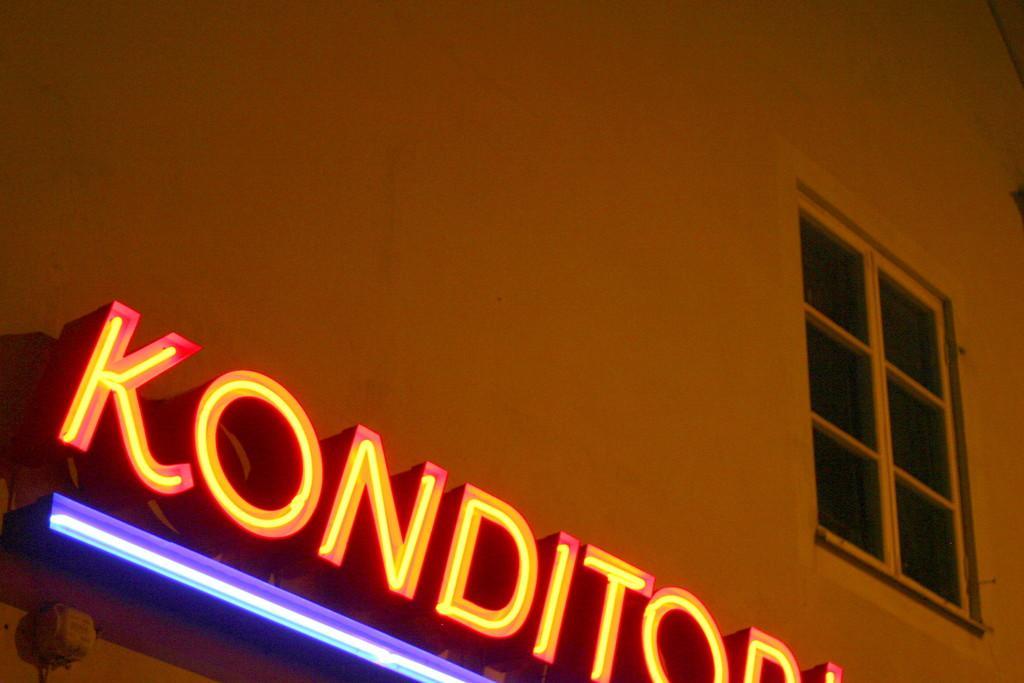Can you describe this image briefly? In this image I can see a building and I can see something written on the building with colorful lights. 